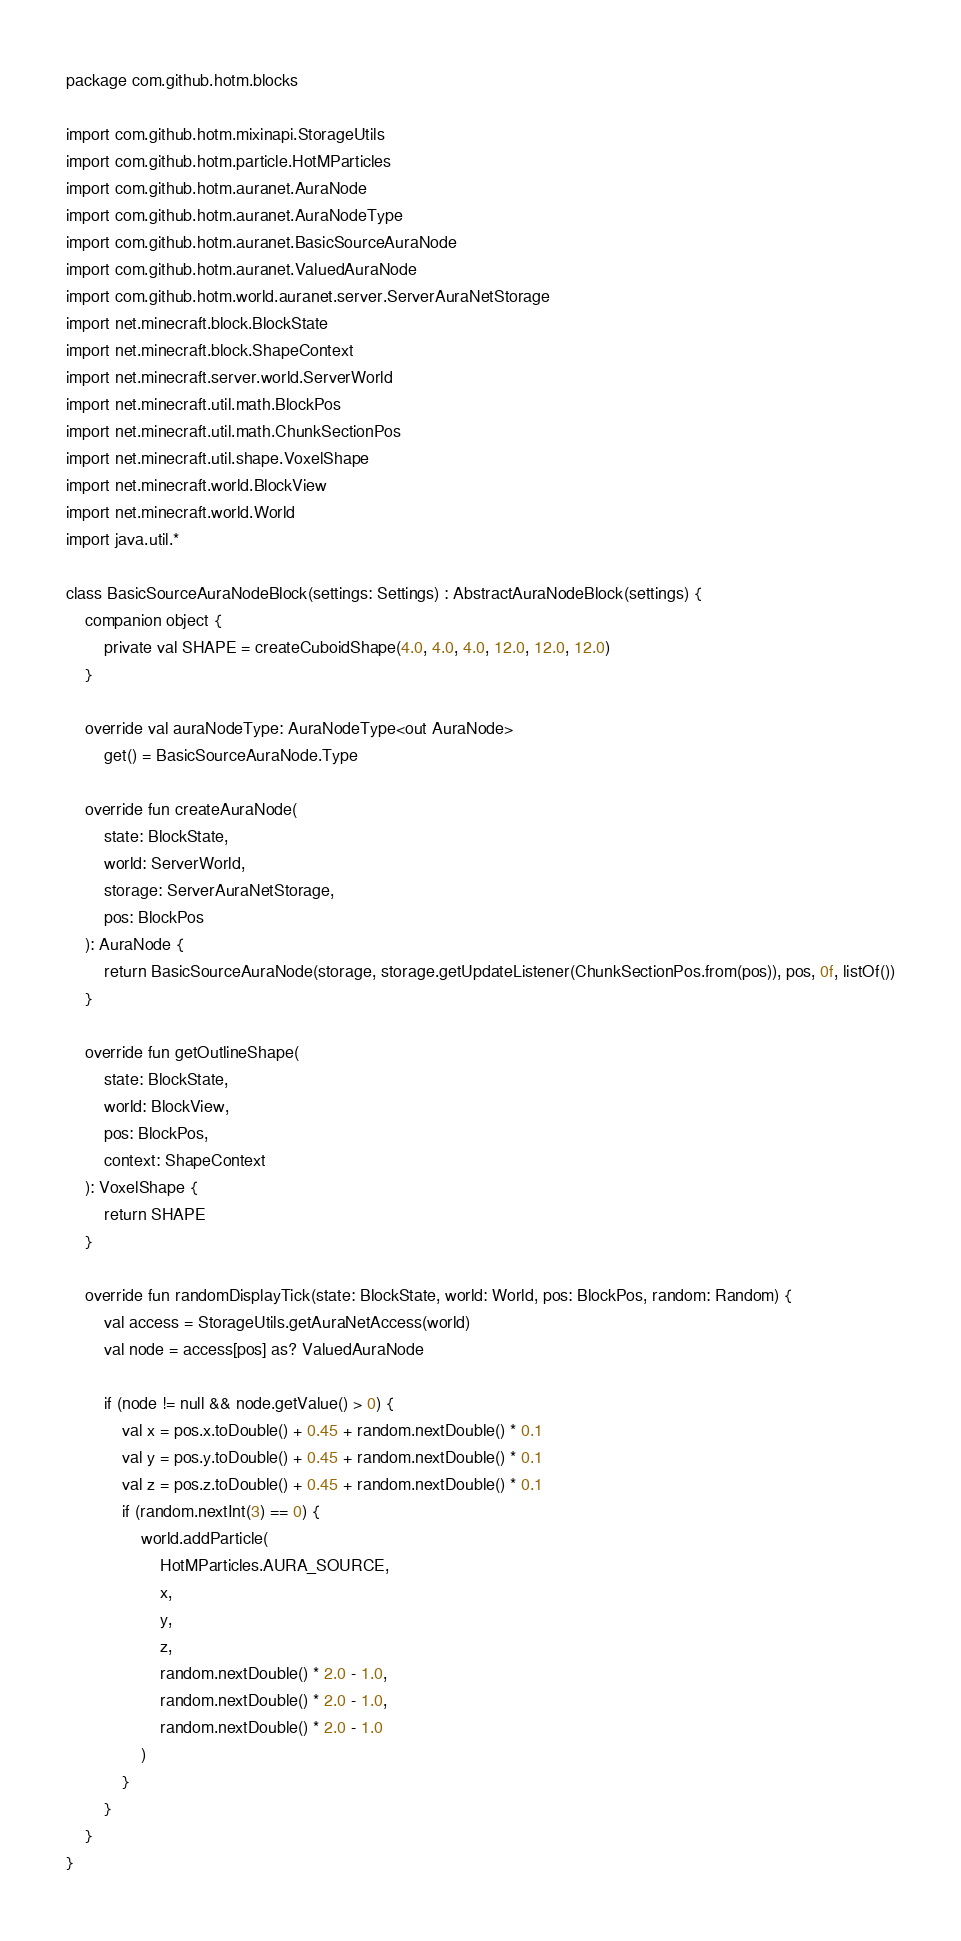<code> <loc_0><loc_0><loc_500><loc_500><_Kotlin_>package com.github.hotm.blocks

import com.github.hotm.mixinapi.StorageUtils
import com.github.hotm.particle.HotMParticles
import com.github.hotm.auranet.AuraNode
import com.github.hotm.auranet.AuraNodeType
import com.github.hotm.auranet.BasicSourceAuraNode
import com.github.hotm.auranet.ValuedAuraNode
import com.github.hotm.world.auranet.server.ServerAuraNetStorage
import net.minecraft.block.BlockState
import net.minecraft.block.ShapeContext
import net.minecraft.server.world.ServerWorld
import net.minecraft.util.math.BlockPos
import net.minecraft.util.math.ChunkSectionPos
import net.minecraft.util.shape.VoxelShape
import net.minecraft.world.BlockView
import net.minecraft.world.World
import java.util.*

class BasicSourceAuraNodeBlock(settings: Settings) : AbstractAuraNodeBlock(settings) {
    companion object {
        private val SHAPE = createCuboidShape(4.0, 4.0, 4.0, 12.0, 12.0, 12.0)
    }

    override val auraNodeType: AuraNodeType<out AuraNode>
        get() = BasicSourceAuraNode.Type

    override fun createAuraNode(
        state: BlockState,
        world: ServerWorld,
        storage: ServerAuraNetStorage,
        pos: BlockPos
    ): AuraNode {
        return BasicSourceAuraNode(storage, storage.getUpdateListener(ChunkSectionPos.from(pos)), pos, 0f, listOf())
    }

    override fun getOutlineShape(
        state: BlockState,
        world: BlockView,
        pos: BlockPos,
        context: ShapeContext
    ): VoxelShape {
        return SHAPE
    }

    override fun randomDisplayTick(state: BlockState, world: World, pos: BlockPos, random: Random) {
        val access = StorageUtils.getAuraNetAccess(world)
        val node = access[pos] as? ValuedAuraNode

        if (node != null && node.getValue() > 0) {
            val x = pos.x.toDouble() + 0.45 + random.nextDouble() * 0.1
            val y = pos.y.toDouble() + 0.45 + random.nextDouble() * 0.1
            val z = pos.z.toDouble() + 0.45 + random.nextDouble() * 0.1
            if (random.nextInt(3) == 0) {
                world.addParticle(
                    HotMParticles.AURA_SOURCE,
                    x,
                    y,
                    z,
                    random.nextDouble() * 2.0 - 1.0,
                    random.nextDouble() * 2.0 - 1.0,
                    random.nextDouble() * 2.0 - 1.0
                )
            }
        }
    }
}</code> 